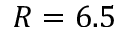<formula> <loc_0><loc_0><loc_500><loc_500>R = 6 . 5</formula> 